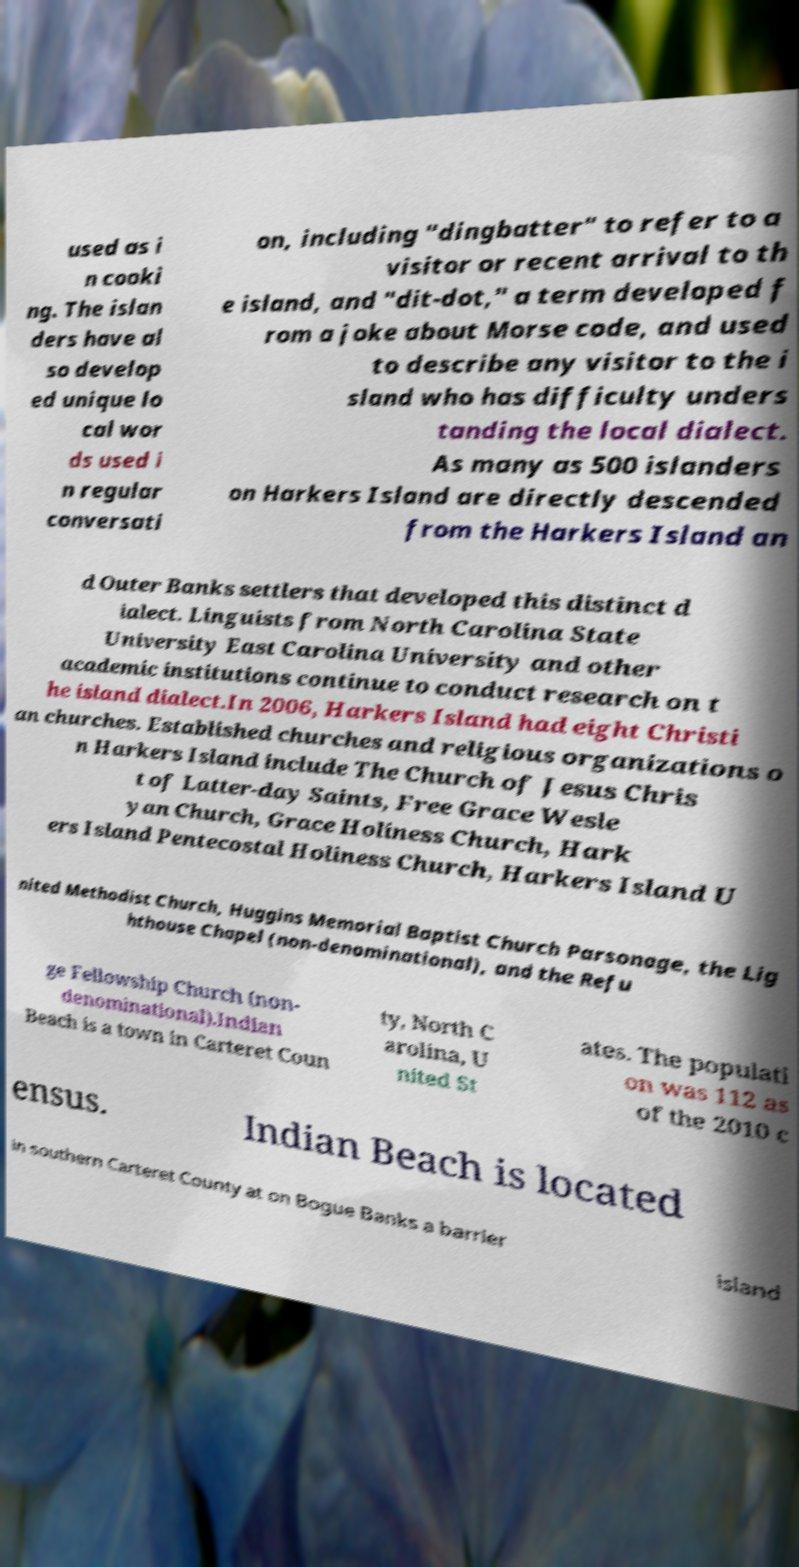Can you read and provide the text displayed in the image?This photo seems to have some interesting text. Can you extract and type it out for me? used as i n cooki ng. The islan ders have al so develop ed unique lo cal wor ds used i n regular conversati on, including "dingbatter" to refer to a visitor or recent arrival to th e island, and "dit-dot," a term developed f rom a joke about Morse code, and used to describe any visitor to the i sland who has difficulty unders tanding the local dialect. As many as 500 islanders on Harkers Island are directly descended from the Harkers Island an d Outer Banks settlers that developed this distinct d ialect. Linguists from North Carolina State University East Carolina University and other academic institutions continue to conduct research on t he island dialect.In 2006, Harkers Island had eight Christi an churches. Established churches and religious organizations o n Harkers Island include The Church of Jesus Chris t of Latter-day Saints, Free Grace Wesle yan Church, Grace Holiness Church, Hark ers Island Pentecostal Holiness Church, Harkers Island U nited Methodist Church, Huggins Memorial Baptist Church Parsonage, the Lig hthouse Chapel (non-denominational), and the Refu ge Fellowship Church (non- denominational).Indian Beach is a town in Carteret Coun ty, North C arolina, U nited St ates. The populati on was 112 as of the 2010 c ensus. Indian Beach is located in southern Carteret County at on Bogue Banks a barrier island 